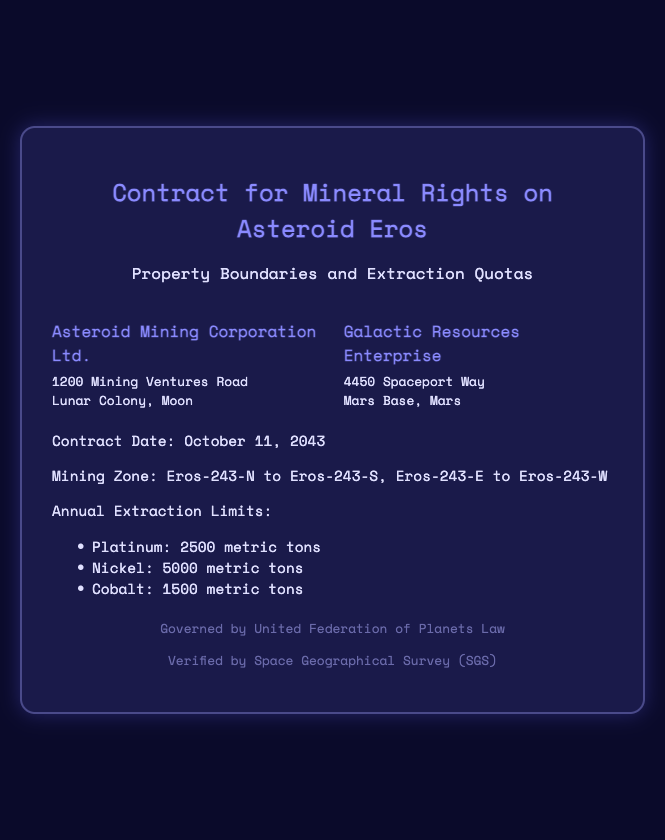What is the name of the first party? The first party named in the document is "Asteroid Mining Corporation Ltd."
Answer: Asteroid Mining Corporation Ltd What is the second party's address? The address for the second party, Galactic Resources Enterprise, is provided in the document as "4450 Spaceport Way, Mars Base, Mars."
Answer: 4450 Spaceport Way, Mars Base, Mars What are the annual extraction limits for Platinum? The document specifies that the annual extraction limit for Platinum is "2500 metric tons."
Answer: 2500 metric tons What are the property boundaries listed in the contract? The document outlines the mining zone as "Eros-243-N to Eros-243-S, Eros-243-E to Eros-243-W."
Answer: Eros-243-N to Eros-243-S, Eros-243-E to Eros-243-W What is the contract date? The date of the contract is stated in the document as "October 11, 2043."
Answer: October 11, 2043 Who verified the contract? The document mentions that the contract was verified by the "Space Geographical Survey (SGS)."
Answer: Space Geographical Survey (SGS) How many metric tons of Nickel can be extracted annually? According to the document, the annual extraction limit for Nickel is "5000 metric tons."
Answer: 5000 metric tons What law governs this contract? The governing law for this contract, as stated in the document, is the "United Federation of Planets Law."
Answer: United Federation of Planets Law 